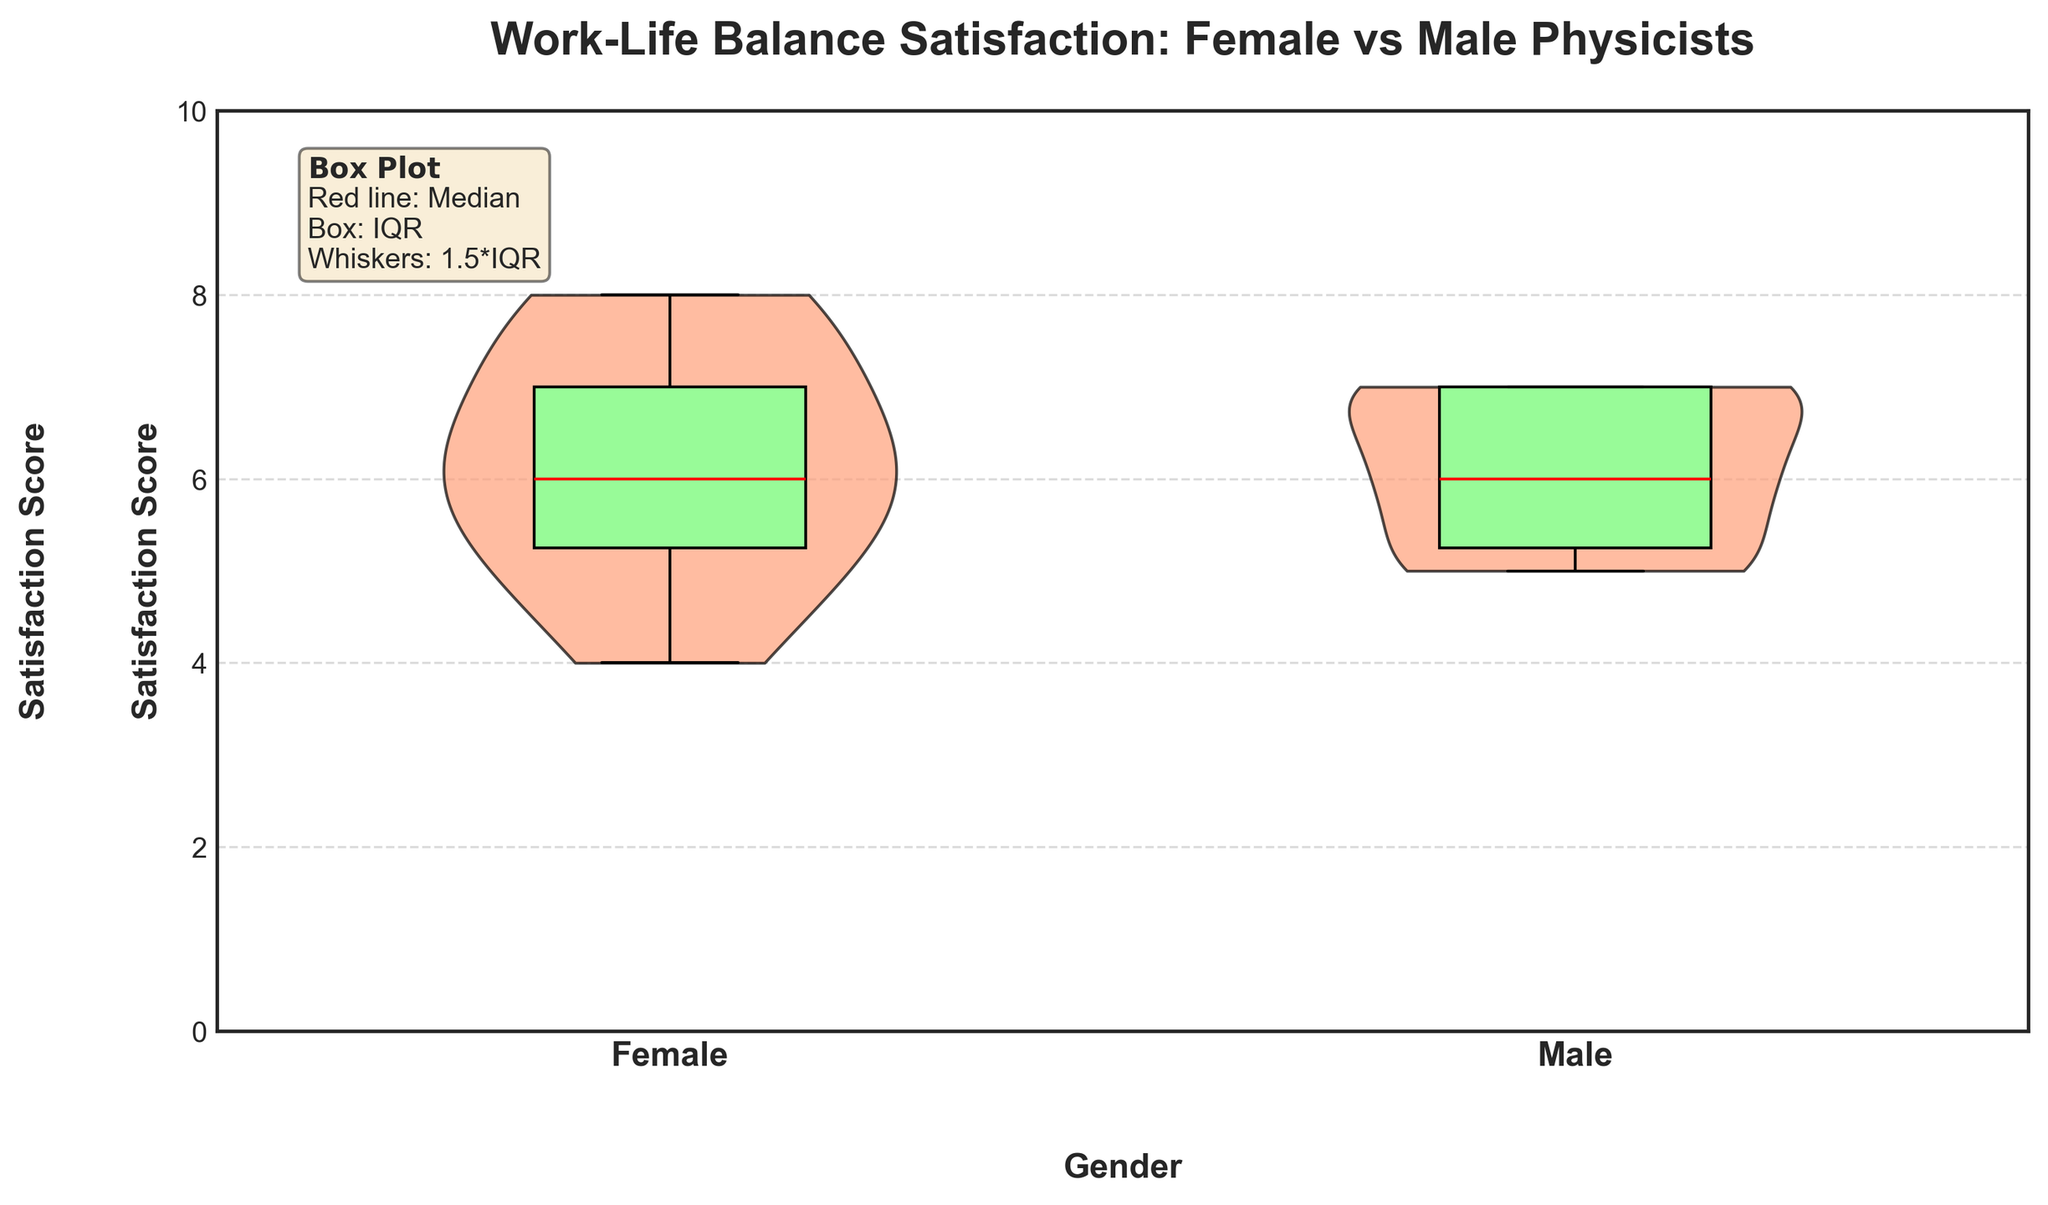What is the title of the plot? The title of the plot is present at the top and it reads 'Work-Life Balance Satisfaction: Female vs Male Physicists'.
Answer: Work-Life Balance Satisfaction: Female vs Male Physicists How many genders are compared in the plot? The plot compares two genders, which can be identified from the labels on the x-axis. The labels are 'Female' and 'Male'.
Answer: Two What is the highest satisfaction score that a female physicist reported? By observing the upper tails of the violin and box plots for females, the highest score is 8.
Answer: 8 How does the median satisfaction score of female physicists compare to male physicists? The median is indicated by the red line within the box plots. For both female and male physicists, the median lines are at the same level, specifically around 6.
Answer: Equal What is the range of work-life balance satisfaction scores for male physicists? The range is determined by the minimum and maximum values of the scores. The minimum score visible is 5, and the maximum score is 7.
Answer: 5 to 7 What information is represented visually by the shape of the violin plots? The shape of the violin plots represents the distribution of satisfaction scores within each gender. Wider sections of the violin indicate a higher density of that particular score.
Answer: Distribution of scores Which gender has a more varied work-life balance satisfaction score? By comparing the widths and deviations within both violins, female physicists show a broader spread ranging from 4 to 8, while male physicists have scores tightly clustered from 5 to 7.
Answer: Female What is the purpose of the box plot inside the violin plot? The box plot provides summary statistics including the median, interquartile range (IQR), and potential outliers, offering additional precision about score distribution.
Answer: Summary statistics What is indicated by the whiskers in the box plots? The whiskers extend to the minimum and maximum scores that fall within 1.5 times the IQR from the quartiles.
Answer: 1.5 times IQR What can you infer about the overall work-life balance satisfaction between the two groups? Both groups have similar median scores (6), but the distribution shows female physicists have a wider range of scores, indicating more varied satisfaction levels. Male physicists' scores are more clustered.
Answer: Similar medians, varied female satisfaction 